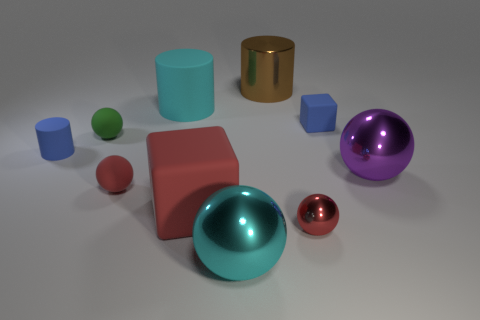Subtract all big metal balls. How many balls are left? 3 Subtract all blocks. How many objects are left? 8 Subtract all brown cylinders. How many red spheres are left? 2 Subtract all purple spheres. How many spheres are left? 4 Subtract 4 spheres. How many spheres are left? 1 Add 5 cyan metal balls. How many cyan metal balls exist? 6 Subtract 2 red balls. How many objects are left? 8 Subtract all blue spheres. Subtract all blue cylinders. How many spheres are left? 5 Subtract all red rubber things. Subtract all cyan matte cylinders. How many objects are left? 7 Add 1 tiny metallic things. How many tiny metallic things are left? 2 